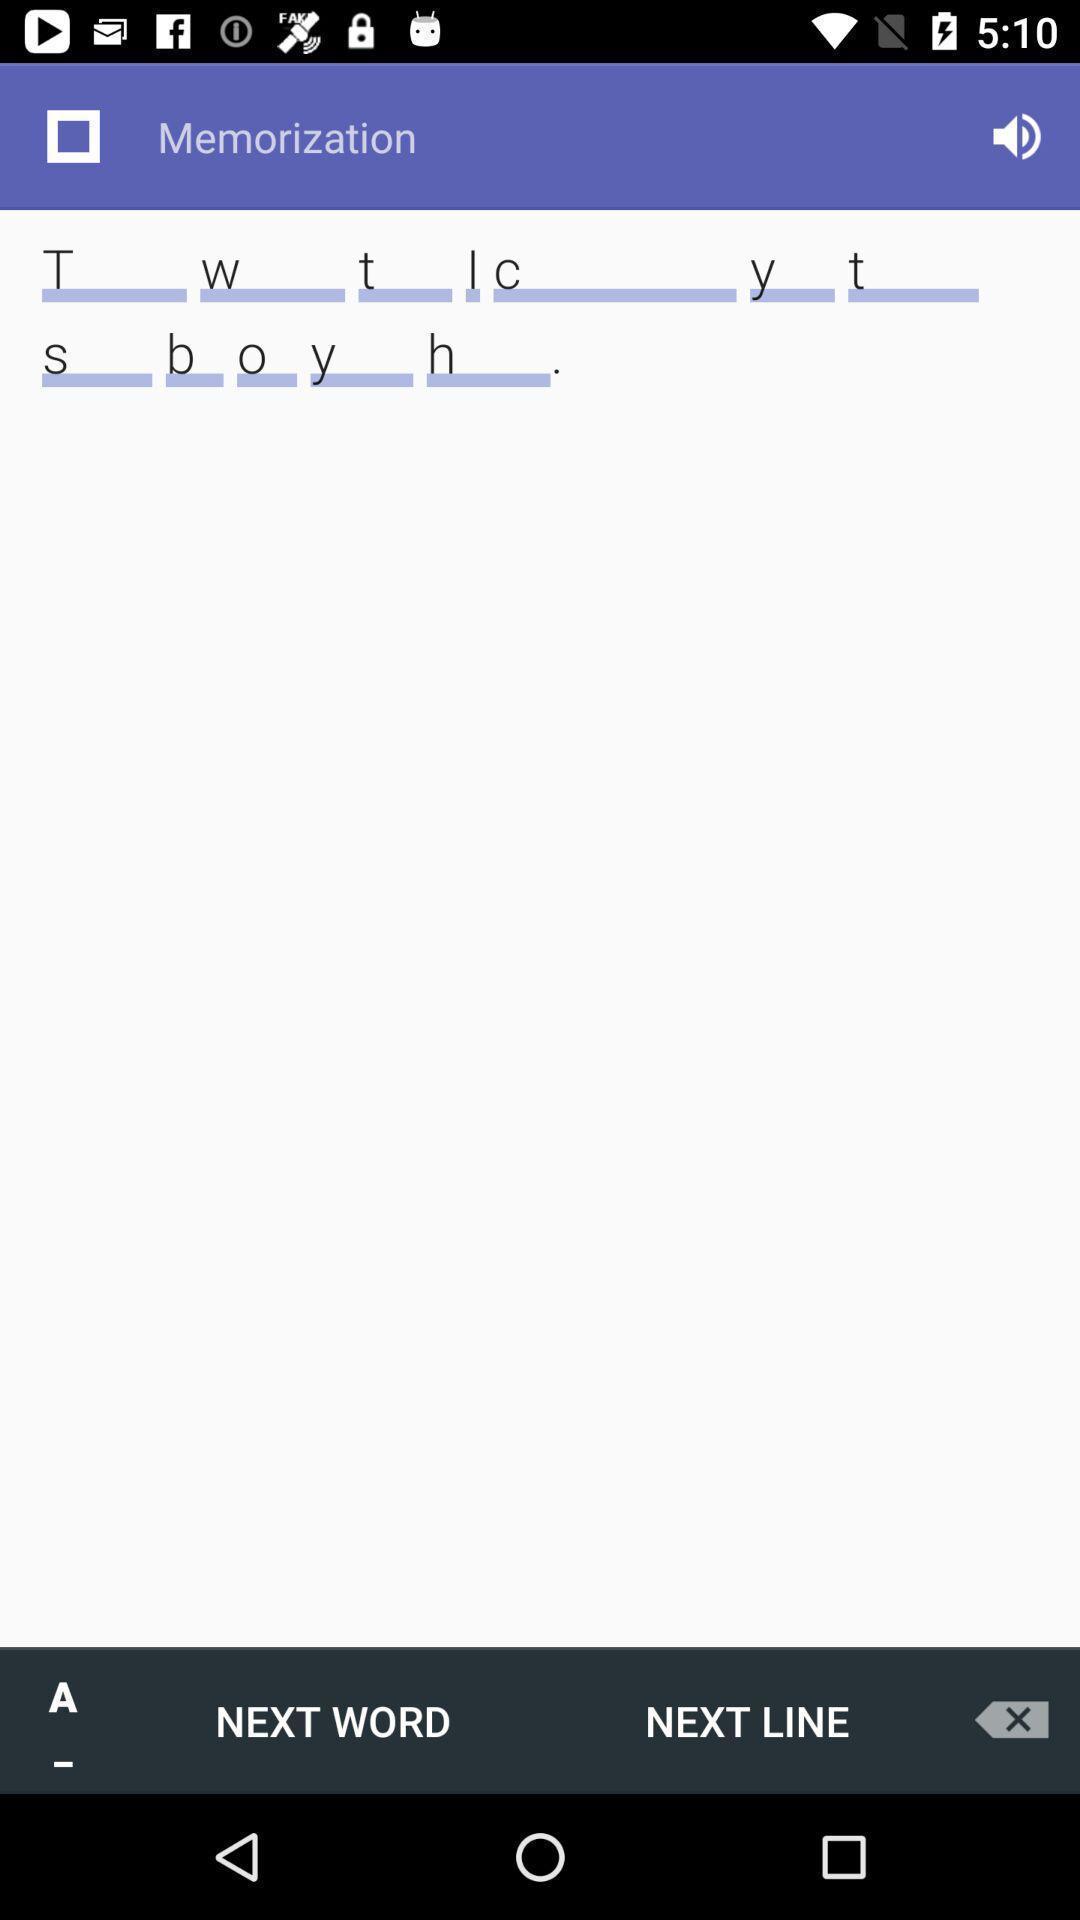Explain the elements present in this screenshot. Page displaying few options available in the app. 